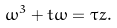<formula> <loc_0><loc_0><loc_500><loc_500>\omega ^ { 3 } + t \omega = \tau z .</formula> 